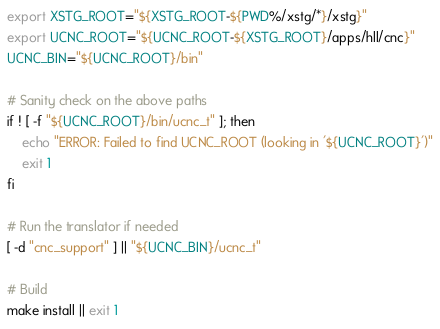<code> <loc_0><loc_0><loc_500><loc_500><_Bash_>export XSTG_ROOT="${XSTG_ROOT-${PWD%/xstg/*}/xstg}"
export UCNC_ROOT="${UCNC_ROOT-${XSTG_ROOT}/apps/hll/cnc}"
UCNC_BIN="${UCNC_ROOT}/bin"

# Sanity check on the above paths
if ! [ -f "${UCNC_ROOT}/bin/ucnc_t" ]; then
    echo "ERROR: Failed to find UCNC_ROOT (looking in '${UCNC_ROOT}')"
    exit 1
fi

# Run the translator if needed
[ -d "cnc_support" ] || "${UCNC_BIN}/ucnc_t"

# Build
make install || exit 1
</code> 